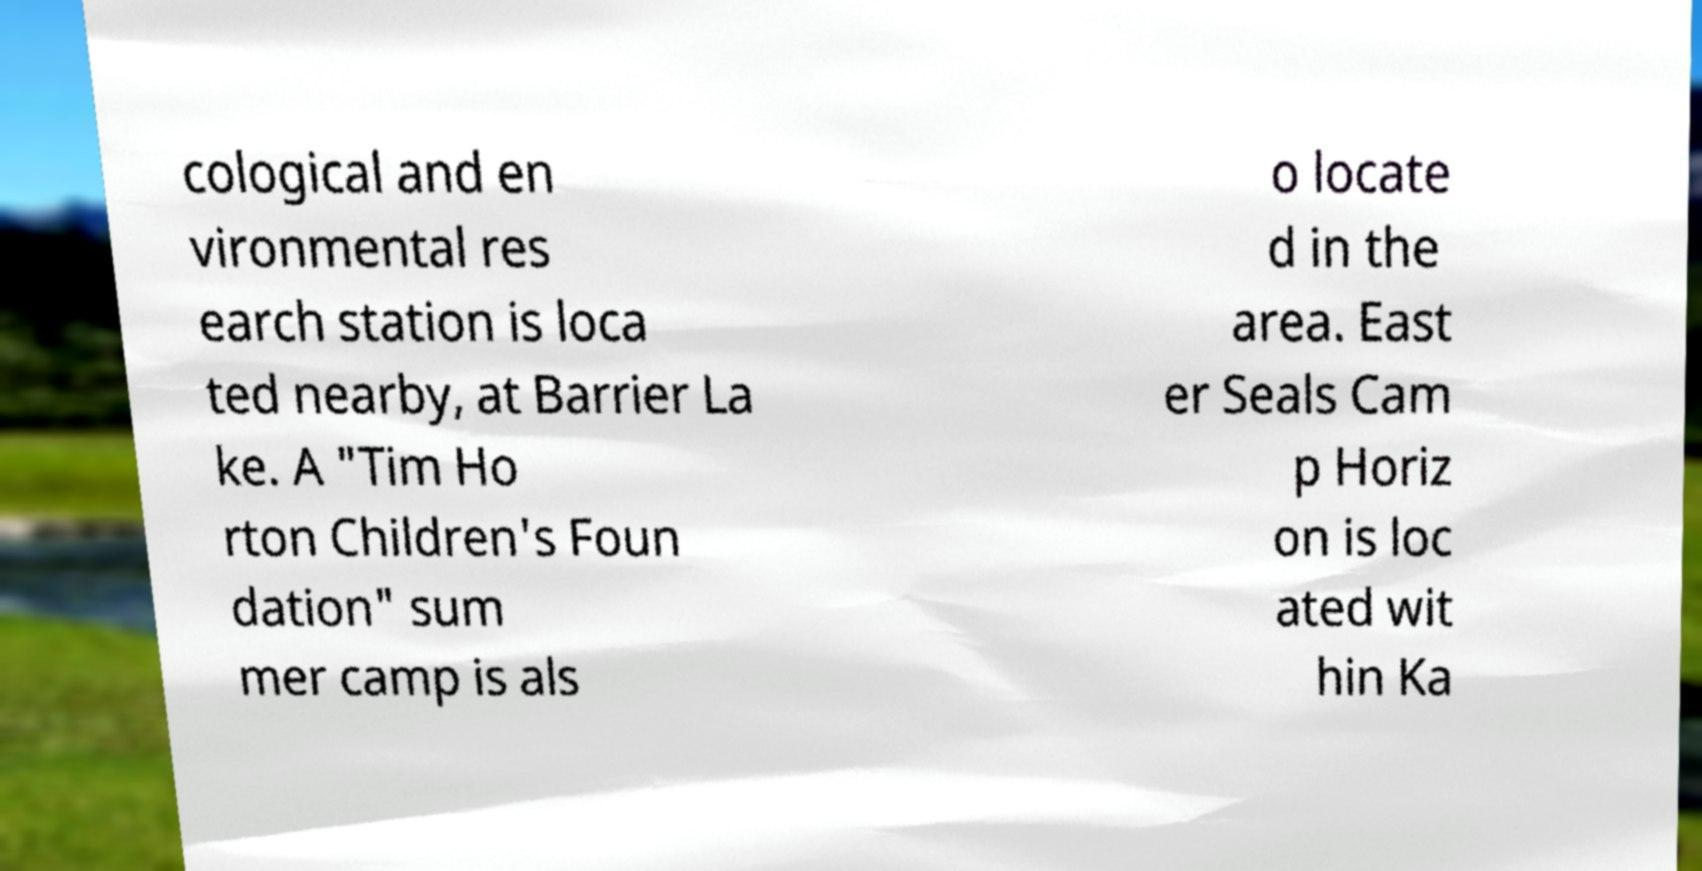I need the written content from this picture converted into text. Can you do that? cological and en vironmental res earch station is loca ted nearby, at Barrier La ke. A "Tim Ho rton Children's Foun dation" sum mer camp is als o locate d in the area. East er Seals Cam p Horiz on is loc ated wit hin Ka 